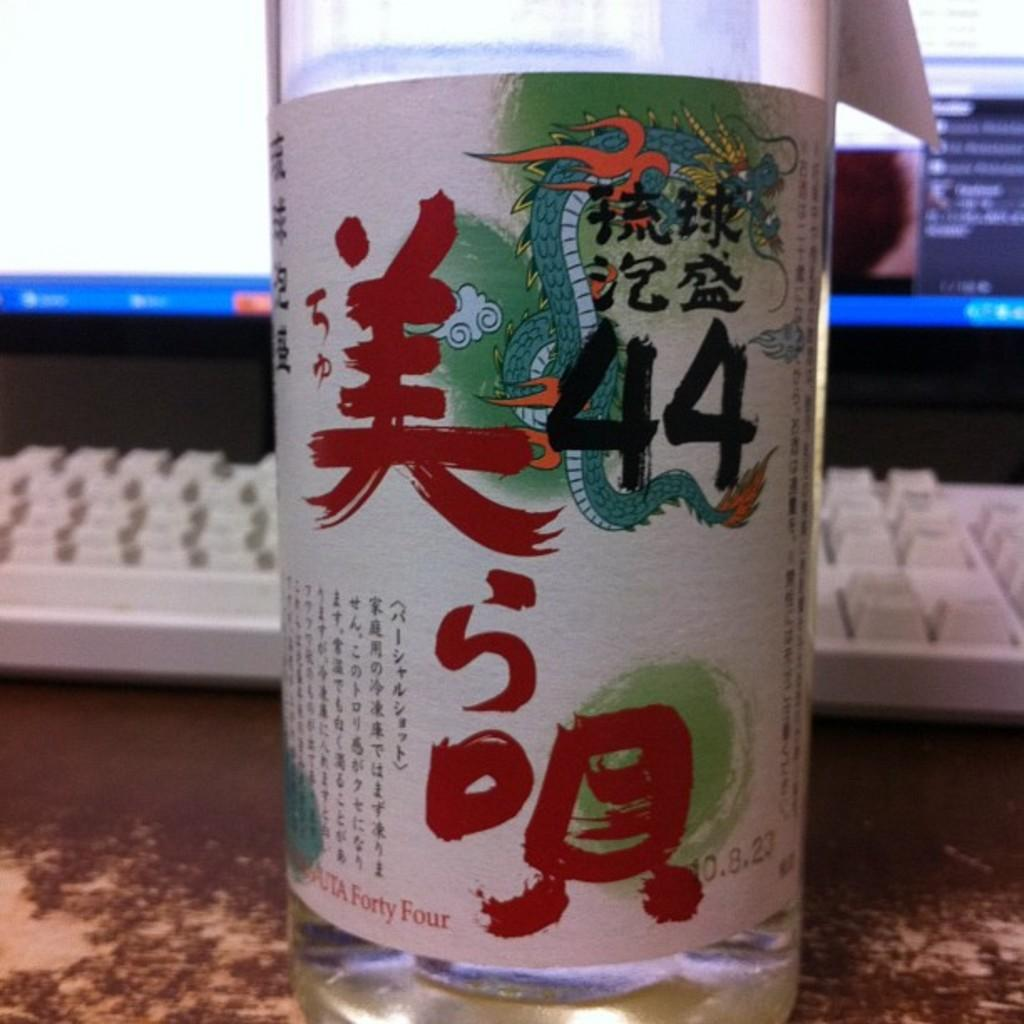<image>
Present a compact description of the photo's key features. The number 44 is on a jar full of clear liquid which has pictures of dragons on it and writing. 